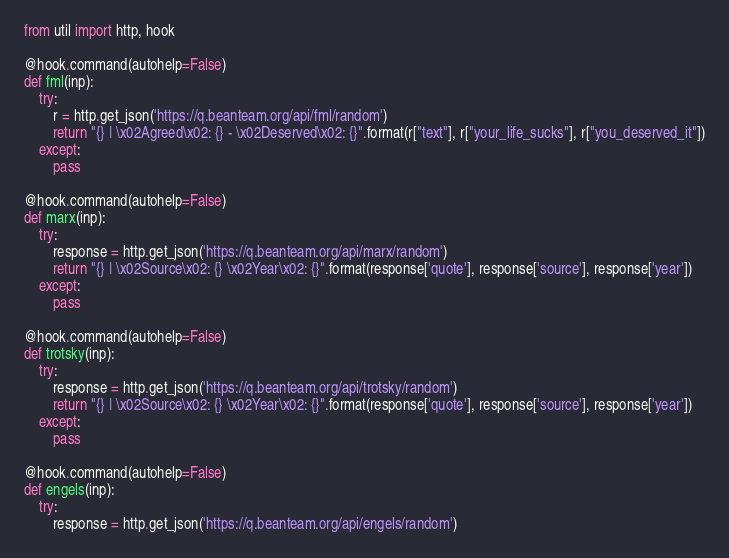Convert code to text. <code><loc_0><loc_0><loc_500><loc_500><_Python_>from util import http, hook

@hook.command(autohelp=False)
def fml(inp):
    try:
        r = http.get_json('https://q.beanteam.org/api/fml/random')
        return "{} | \x02Agreed\x02: {} - \x02Deserved\x02: {}".format(r["text"], r["your_life_sucks"], r["you_deserved_it"])
    except:
        pass

@hook.command(autohelp=False)
def marx(inp):
    try:
        response = http.get_json('https://q.beanteam.org/api/marx/random')
        return "{} | \x02Source\x02: {} \x02Year\x02: {}".format(response['quote'], response['source'], response['year'])
    except:
        pass

@hook.command(autohelp=False)
def trotsky(inp):
    try:
        response = http.get_json('https://q.beanteam.org/api/trotsky/random')
        return "{} | \x02Source\x02: {} \x02Year\x02: {}".format(response['quote'], response['source'], response['year'])
    except:
        pass

@hook.command(autohelp=False)
def engels(inp):
    try:
        response = http.get_json('https://q.beanteam.org/api/engels/random')</code> 